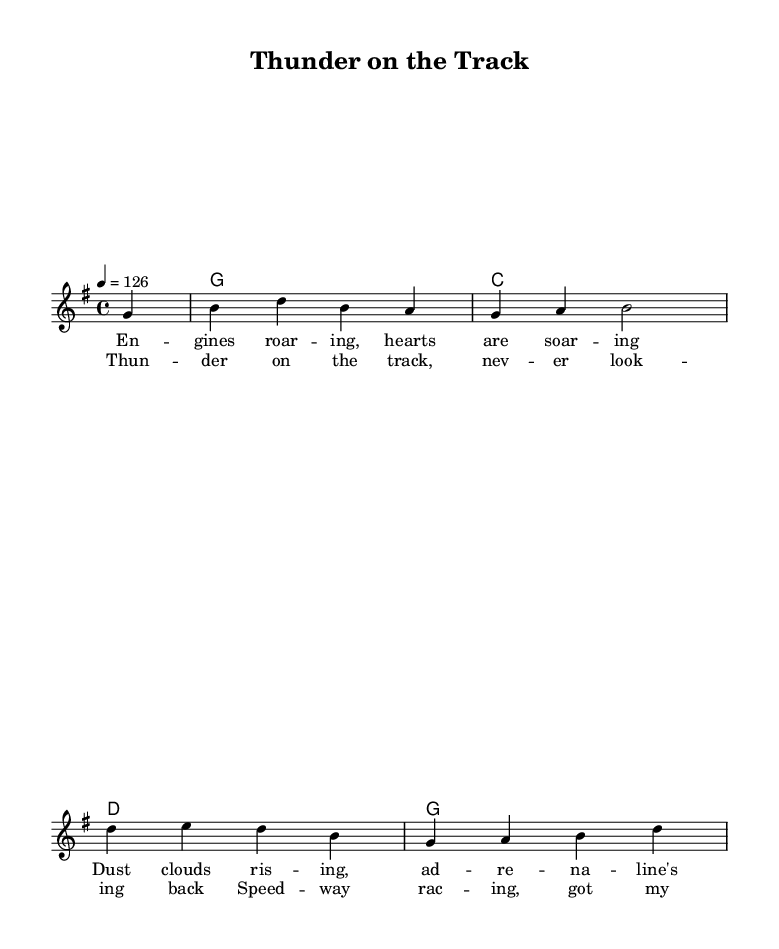What is the key signature of this music? The key signature is G major, which has one sharp (F#). You can determine this by looking at the key signature section at the beginning of the score.
Answer: G major What is the time signature of this music? The time signature is 4/4, which can be found at the beginning of the score. This indicates there are four beats per measure.
Answer: 4/4 What is the tempo marking in this music? The tempo marking is a quarter note = 126. This is specified at the start of the score, indicating the speed of the piece.
Answer: 126 How many measures are in the melody section? The melody section consists of six measures, which can be counted from the beginning to the end of the melody line.
Answer: 6 What is the title of this song? The title is "Thunder on the Track," which is provided in the header of the score above the music.
Answer: Thunder on the Track What type of upbeat is characterized in the lyrics? The lyrics describe excitement and thrill, notably using phrases like "thunder on the track" and "heart racing," emphasizing the adrenaline of racing.
Answer: Adrenaline What is the primary musical genre of this piece? The primary musical genre is country rock, which is defined by its upbeat tempo and themes related to motorsports and racing as shown in the lyrics and style of the melody.
Answer: Country rock 